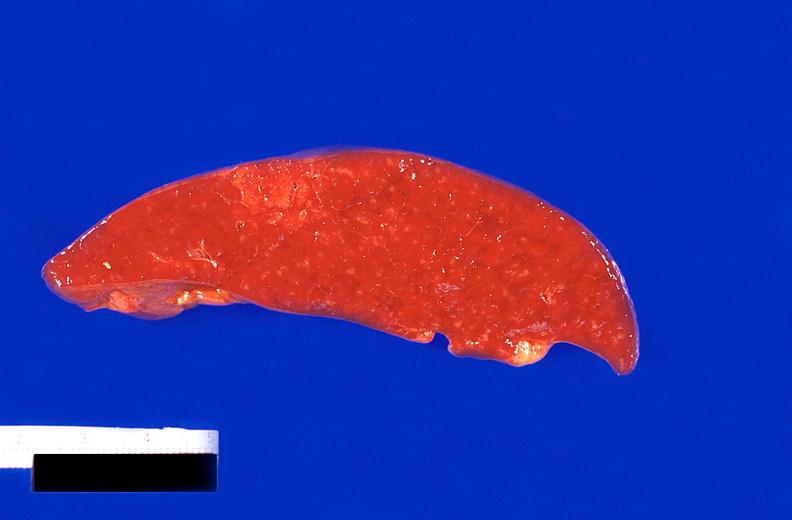does this image show spleen, infarcts, thrombotic thrombocytopenic purpura?
Answer the question using a single word or phrase. Yes 